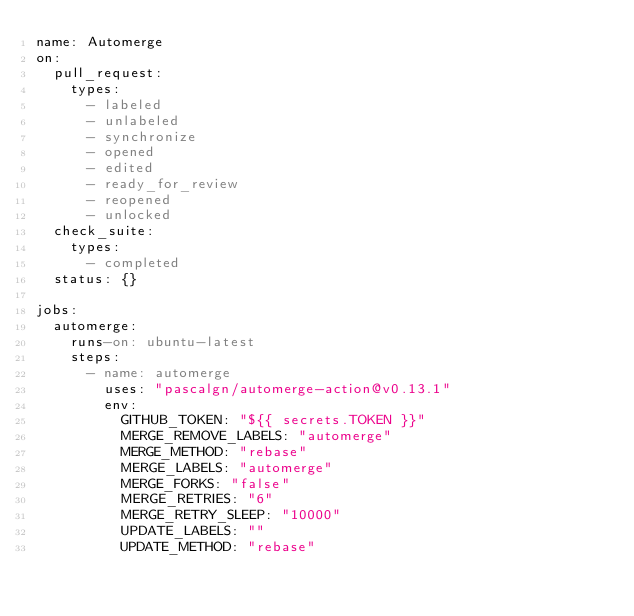Convert code to text. <code><loc_0><loc_0><loc_500><loc_500><_YAML_>name: Automerge
on:
  pull_request:
    types:
      - labeled
      - unlabeled
      - synchronize
      - opened
      - edited
      - ready_for_review
      - reopened
      - unlocked
  check_suite:
    types:
      - completed
  status: {}

jobs:
  automerge:
    runs-on: ubuntu-latest
    steps:
      - name: automerge
        uses: "pascalgn/automerge-action@v0.13.1"
        env:
          GITHUB_TOKEN: "${{ secrets.TOKEN }}"
          MERGE_REMOVE_LABELS: "automerge"
          MERGE_METHOD: "rebase"
          MERGE_LABELS: "automerge"
          MERGE_FORKS: "false"
          MERGE_RETRIES: "6"
          MERGE_RETRY_SLEEP: "10000"
          UPDATE_LABELS: ""
          UPDATE_METHOD: "rebase"</code> 